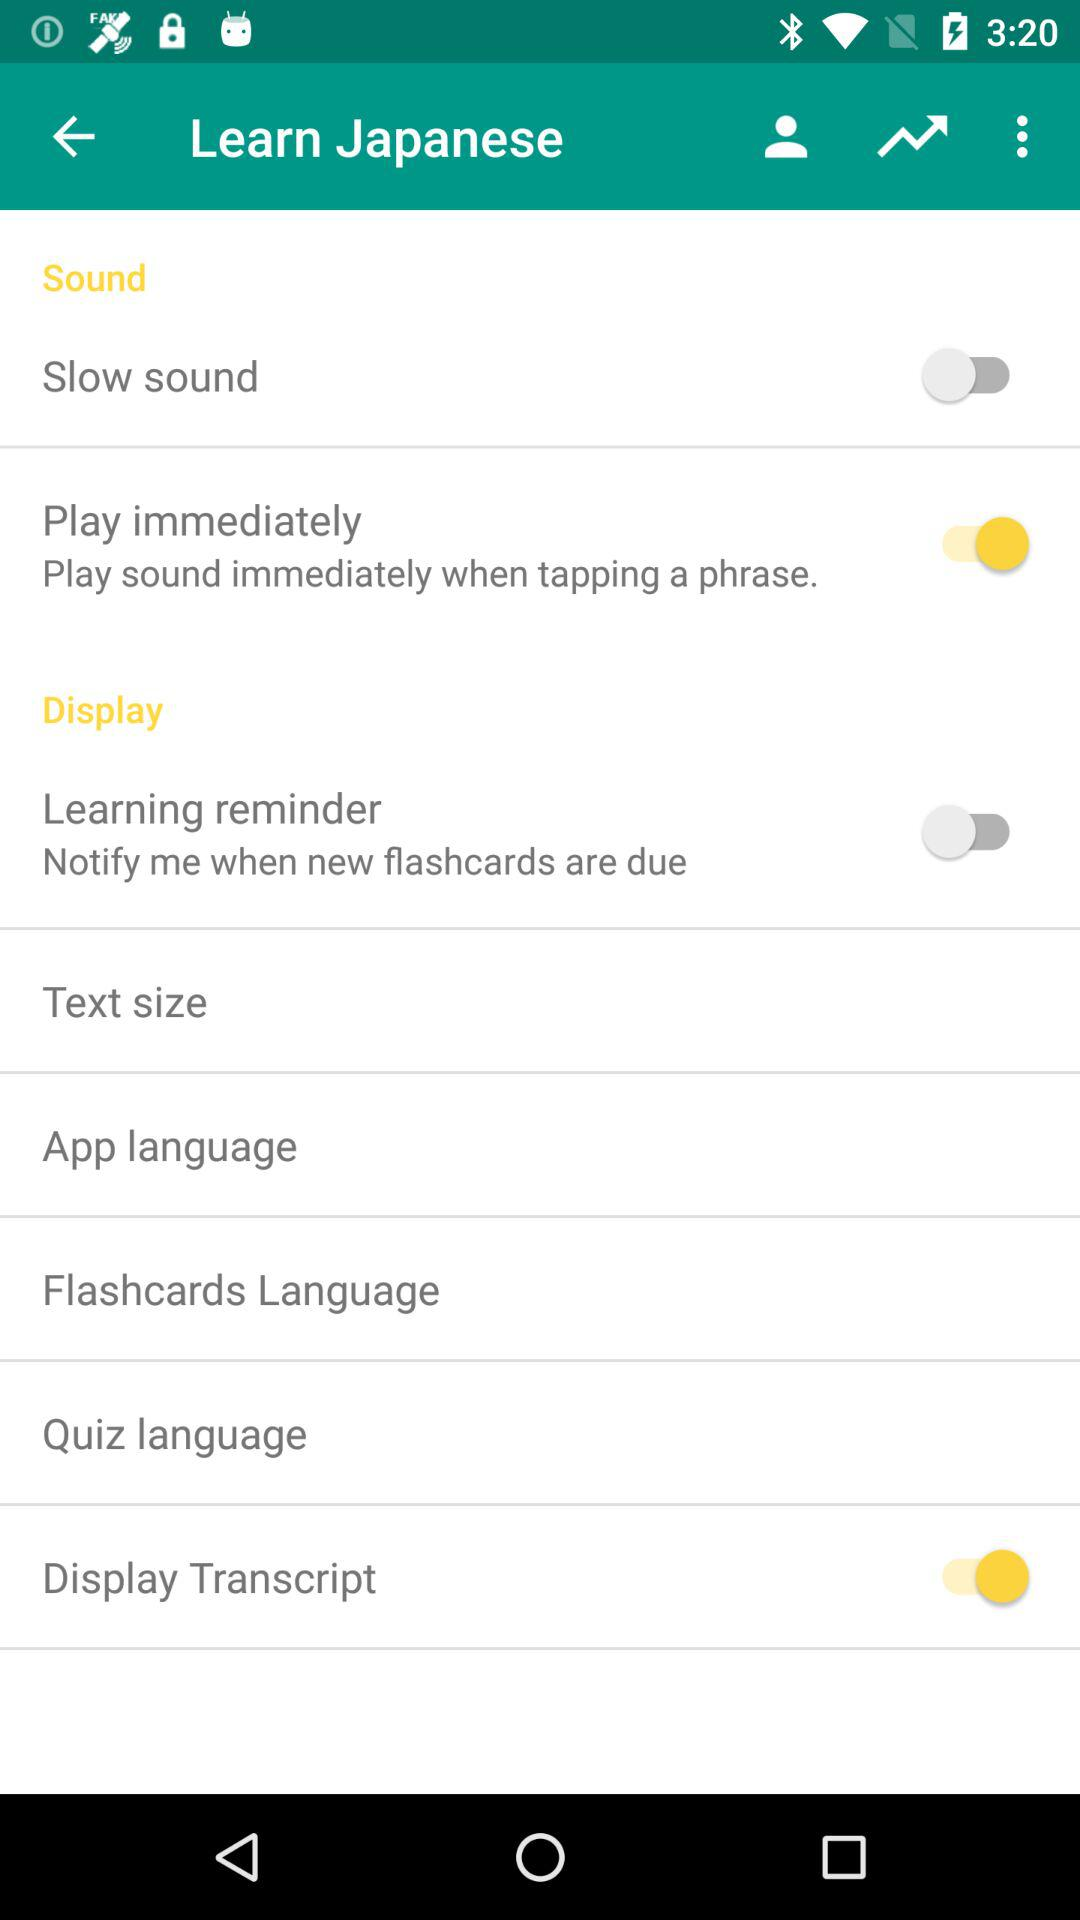What is the status of the "Learning reminder" setting? The status of the "Learning reminder" setting is "off". 